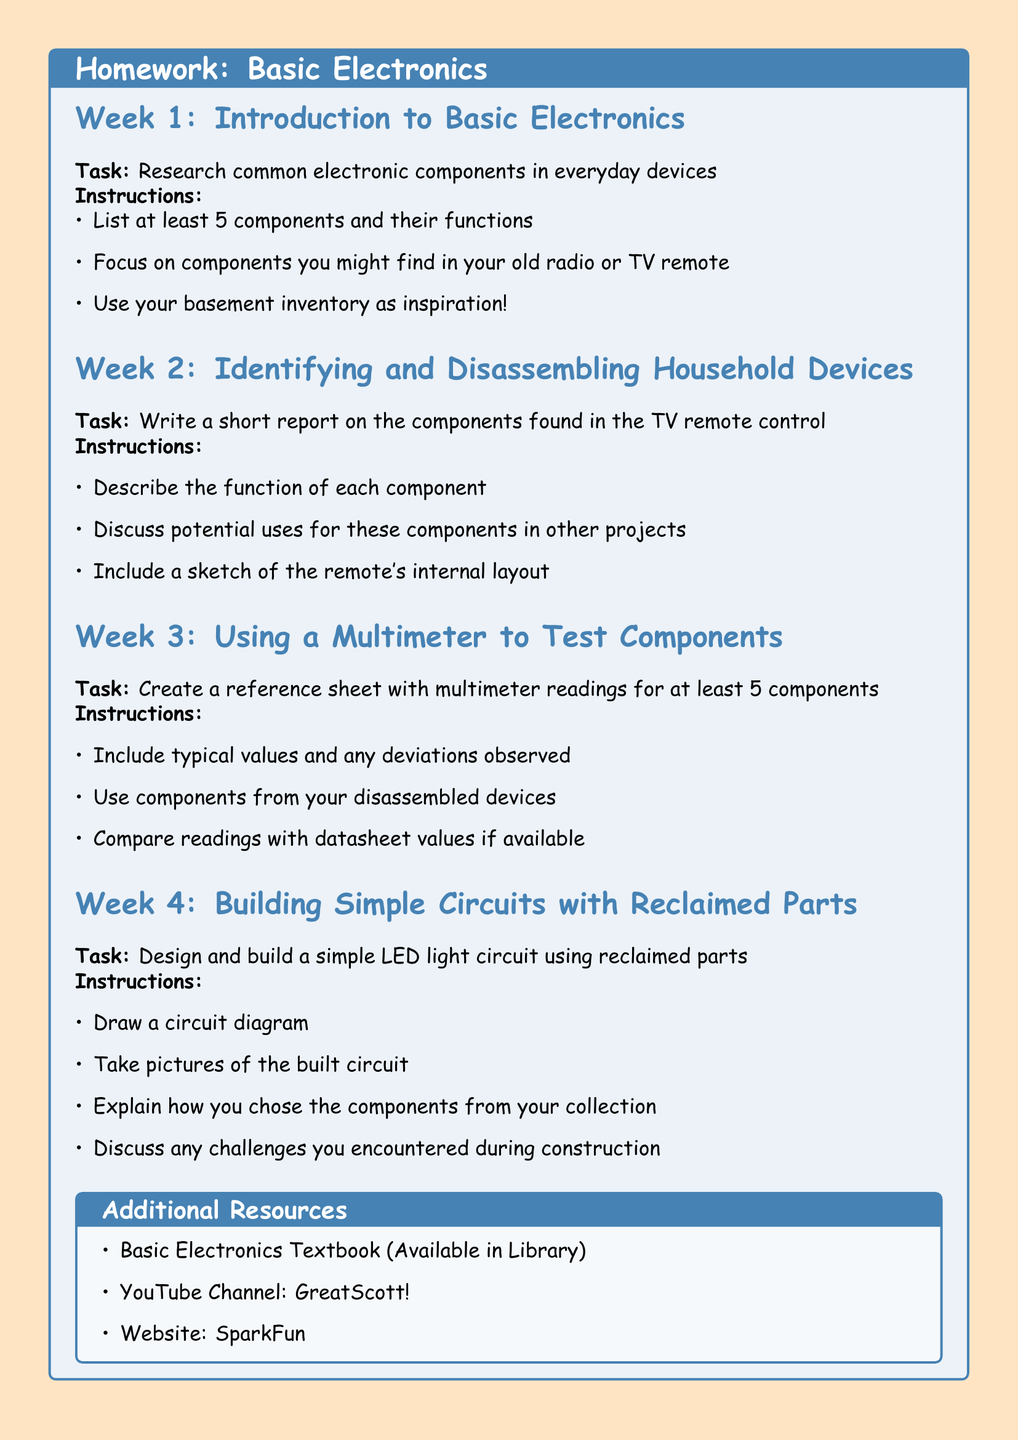What is the title of Week 1? The title is specified at the beginning of Week 1 in the document as "Introduction to Basic Electronics."
Answer: Introduction to Basic Electronics How many components should be listed in Week 1? The document states that at least 5 components should be listed in Week 1.
Answer: 5 What should be included in the Week 2 report? The instructions for Week 2 specify the report should describe the function of each component and discuss potential uses.
Answer: Function and potential uses What is the task in Week 3? The task involves creating a reference sheet with multimeter readings for components.
Answer: Create a reference sheet What should be sketched in Week 2? It is instructed to include a sketch of the remote's internal layout in the Week 2 report.
Answer: Internal layout sketch What is the focus of Week 4? The focus of Week 4 is on designing and building a simple LED light circuit.
Answer: Simple LED light circuit Which YouTube channel is recommended? The document lists "GreatScott!" as a recommended YouTube channel.
Answer: GreatScott! What is the color scheme used for the background? The document specifies the background color as "retro" with the RGB value of 255, 228, 196.
Answer: retro 